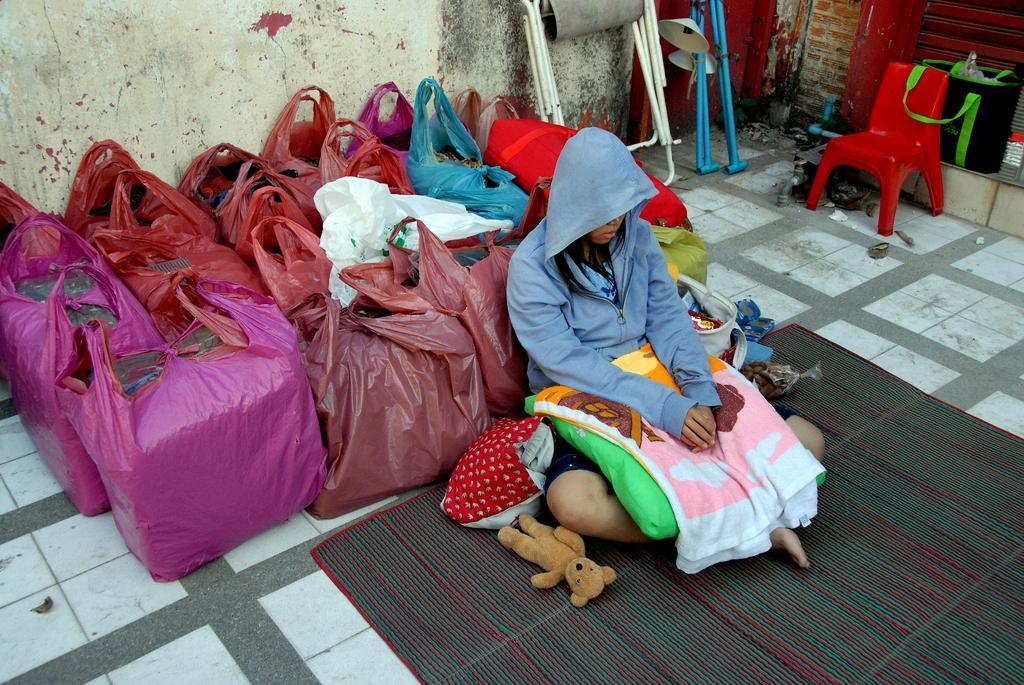Describe this image in one or two sentences. In this image we can see a person sitting on the mat, there are some carry bags, chairs and some other objects, also we can see the wall. 